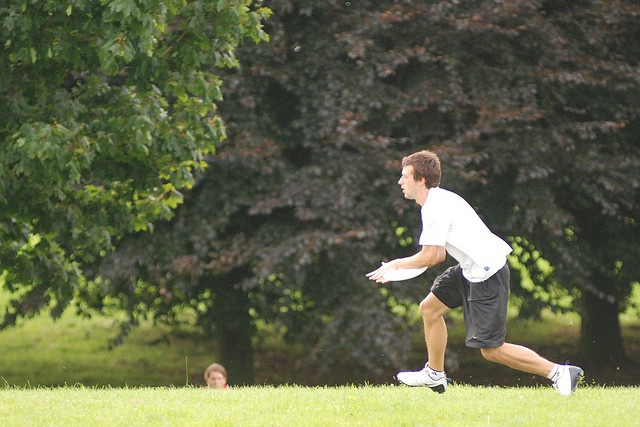Describe the objects in this image and their specific colors. I can see people in black, white, gray, and tan tones, people in black, tan, and gray tones, and frisbee in black, white, tan, lightgray, and gray tones in this image. 